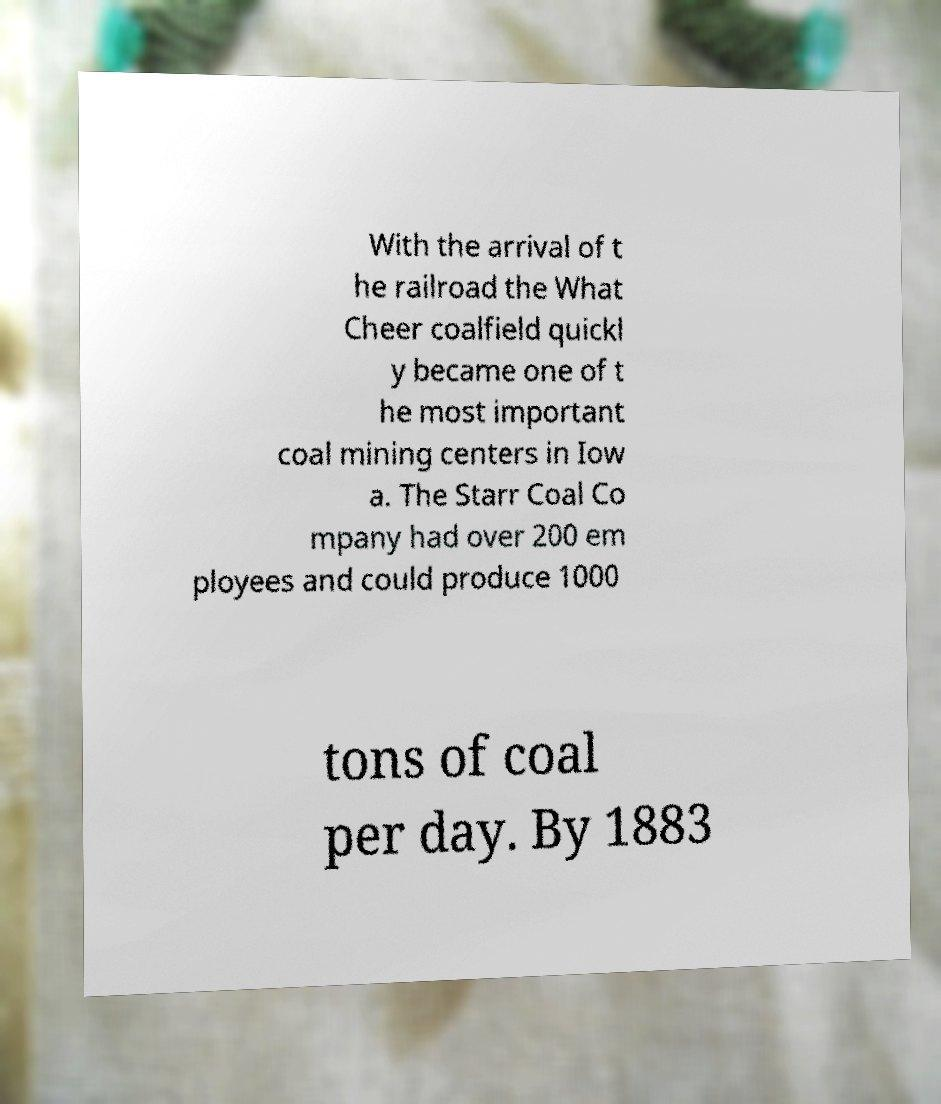Please identify and transcribe the text found in this image. With the arrival of t he railroad the What Cheer coalfield quickl y became one of t he most important coal mining centers in Iow a. The Starr Coal Co mpany had over 200 em ployees and could produce 1000 tons of coal per day. By 1883 